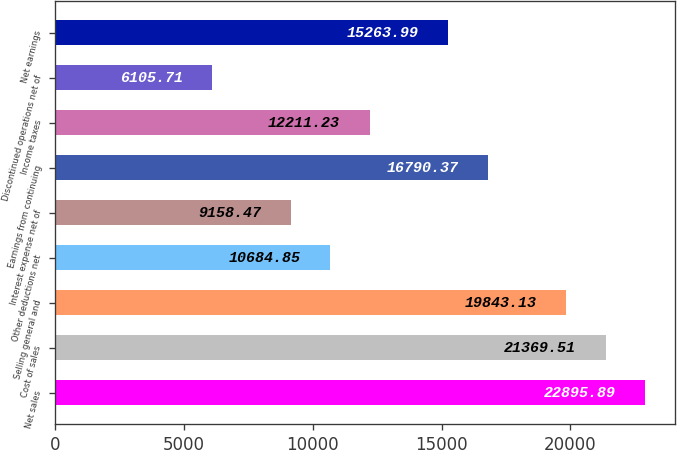Convert chart to OTSL. <chart><loc_0><loc_0><loc_500><loc_500><bar_chart><fcel>Net sales<fcel>Cost of sales<fcel>Selling general and<fcel>Other deductions net<fcel>Interest expense net of<fcel>Earnings from continuing<fcel>Income taxes<fcel>Discontinued operations net of<fcel>Net earnings<nl><fcel>22895.9<fcel>21369.5<fcel>19843.1<fcel>10684.9<fcel>9158.47<fcel>16790.4<fcel>12211.2<fcel>6105.71<fcel>15264<nl></chart> 